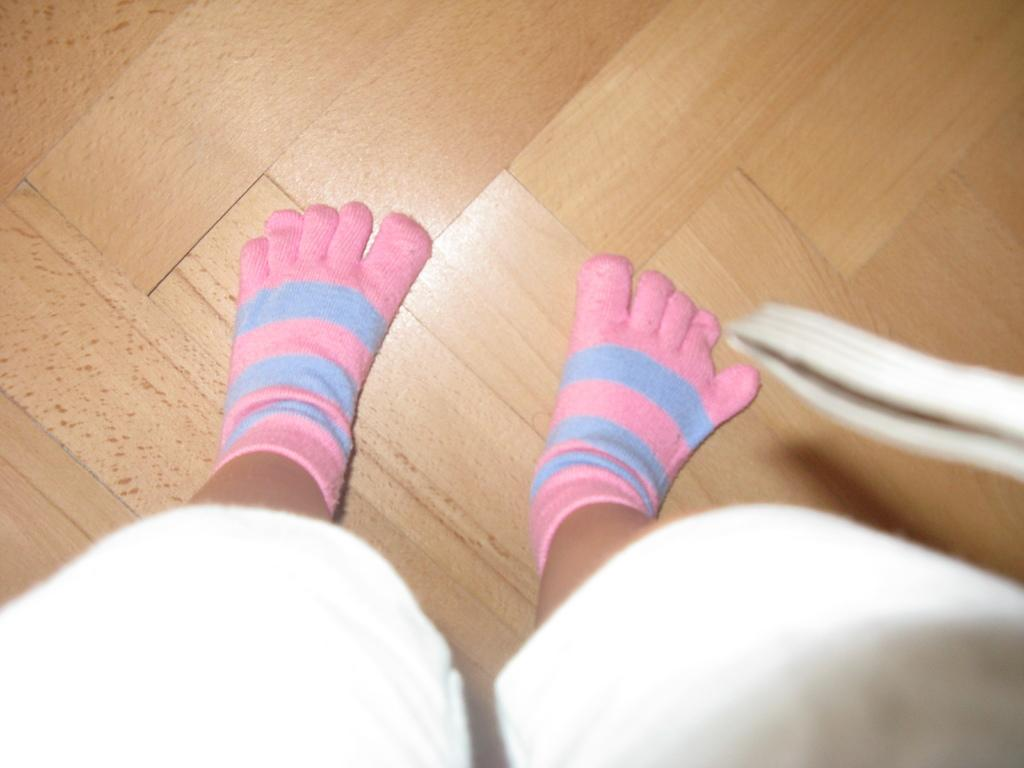What part of a person's body is visible in the image? There is a person's leg visible in the image. What is covering the leg in the image? The leg is covered with socks. How many pizzas are stacked on the side of the leg in the image? There are no pizzas present in the image; only a leg covered with socks is visible. 